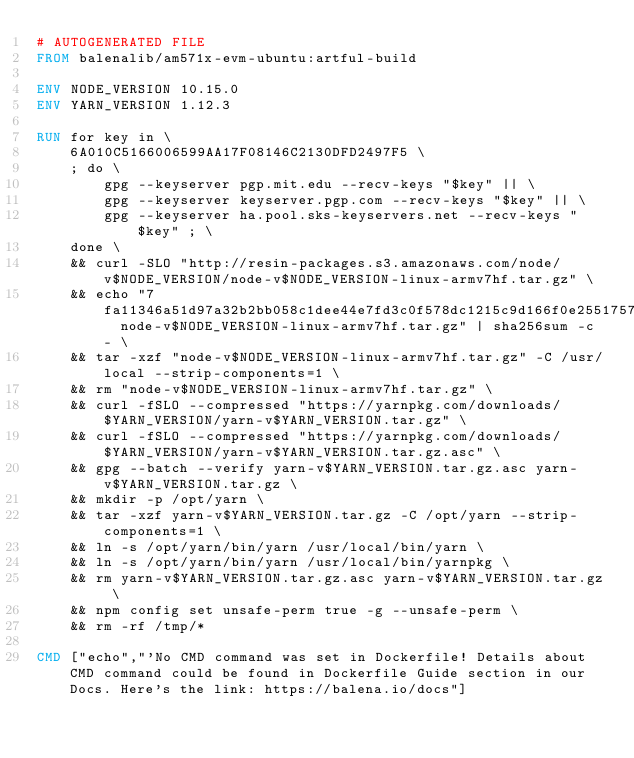Convert code to text. <code><loc_0><loc_0><loc_500><loc_500><_Dockerfile_># AUTOGENERATED FILE
FROM balenalib/am571x-evm-ubuntu:artful-build

ENV NODE_VERSION 10.15.0
ENV YARN_VERSION 1.12.3

RUN for key in \
	6A010C5166006599AA17F08146C2130DFD2497F5 \
	; do \
		gpg --keyserver pgp.mit.edu --recv-keys "$key" || \
		gpg --keyserver keyserver.pgp.com --recv-keys "$key" || \
		gpg --keyserver ha.pool.sks-keyservers.net --recv-keys "$key" ; \
	done \
	&& curl -SLO "http://resin-packages.s3.amazonaws.com/node/v$NODE_VERSION/node-v$NODE_VERSION-linux-armv7hf.tar.gz" \
	&& echo "7fa11346a51d97a32b2bb058c1dee44e7fd3c0f578dc1215c9d166f0e2551757  node-v$NODE_VERSION-linux-armv7hf.tar.gz" | sha256sum -c - \
	&& tar -xzf "node-v$NODE_VERSION-linux-armv7hf.tar.gz" -C /usr/local --strip-components=1 \
	&& rm "node-v$NODE_VERSION-linux-armv7hf.tar.gz" \
	&& curl -fSLO --compressed "https://yarnpkg.com/downloads/$YARN_VERSION/yarn-v$YARN_VERSION.tar.gz" \
	&& curl -fSLO --compressed "https://yarnpkg.com/downloads/$YARN_VERSION/yarn-v$YARN_VERSION.tar.gz.asc" \
	&& gpg --batch --verify yarn-v$YARN_VERSION.tar.gz.asc yarn-v$YARN_VERSION.tar.gz \
	&& mkdir -p /opt/yarn \
	&& tar -xzf yarn-v$YARN_VERSION.tar.gz -C /opt/yarn --strip-components=1 \
	&& ln -s /opt/yarn/bin/yarn /usr/local/bin/yarn \
	&& ln -s /opt/yarn/bin/yarn /usr/local/bin/yarnpkg \
	&& rm yarn-v$YARN_VERSION.tar.gz.asc yarn-v$YARN_VERSION.tar.gz \
	&& npm config set unsafe-perm true -g --unsafe-perm \
	&& rm -rf /tmp/*

CMD ["echo","'No CMD command was set in Dockerfile! Details about CMD command could be found in Dockerfile Guide section in our Docs. Here's the link: https://balena.io/docs"]</code> 